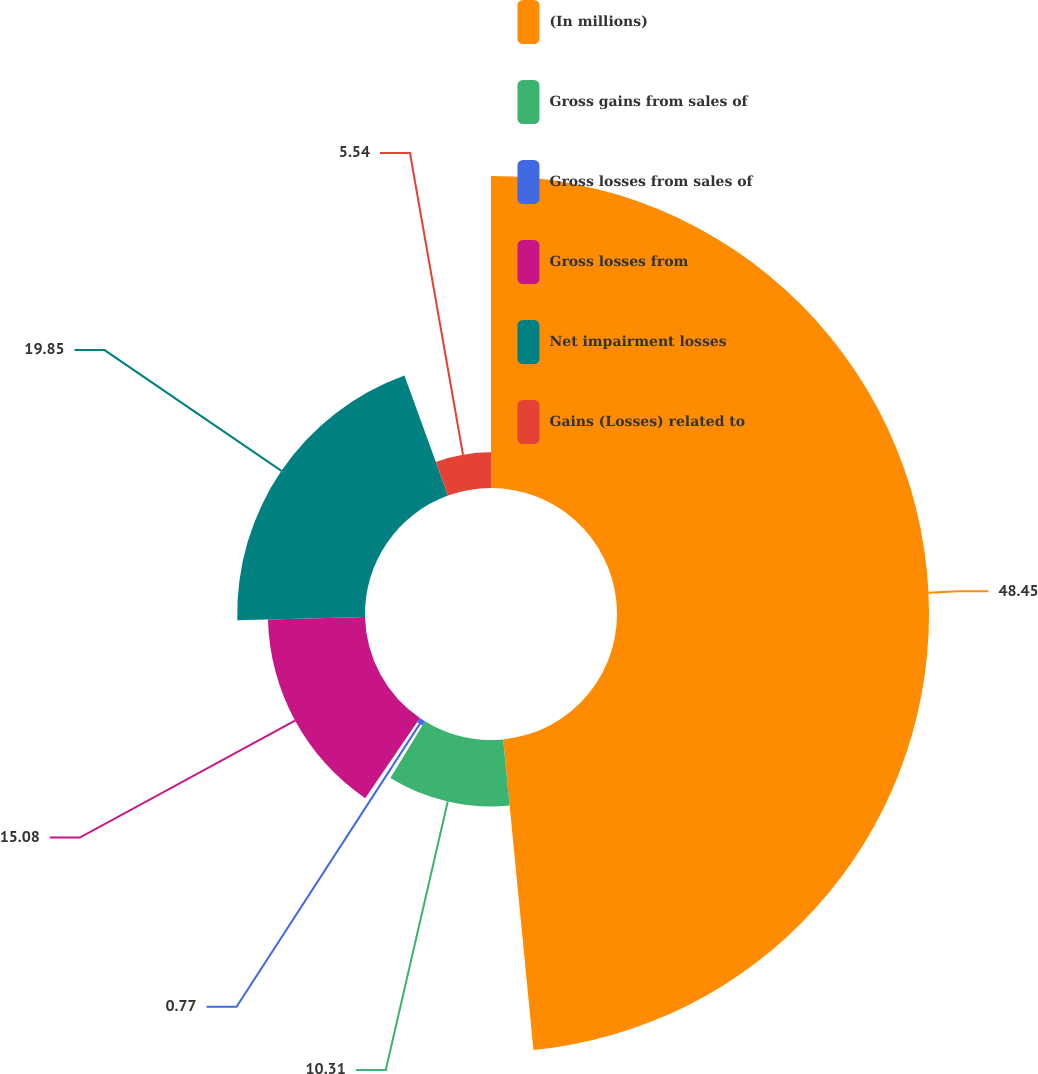Convert chart to OTSL. <chart><loc_0><loc_0><loc_500><loc_500><pie_chart><fcel>(In millions)<fcel>Gross gains from sales of<fcel>Gross losses from sales of<fcel>Gross losses from<fcel>Net impairment losses<fcel>Gains (Losses) related to<nl><fcel>48.46%<fcel>10.31%<fcel>0.77%<fcel>15.08%<fcel>19.85%<fcel>5.54%<nl></chart> 